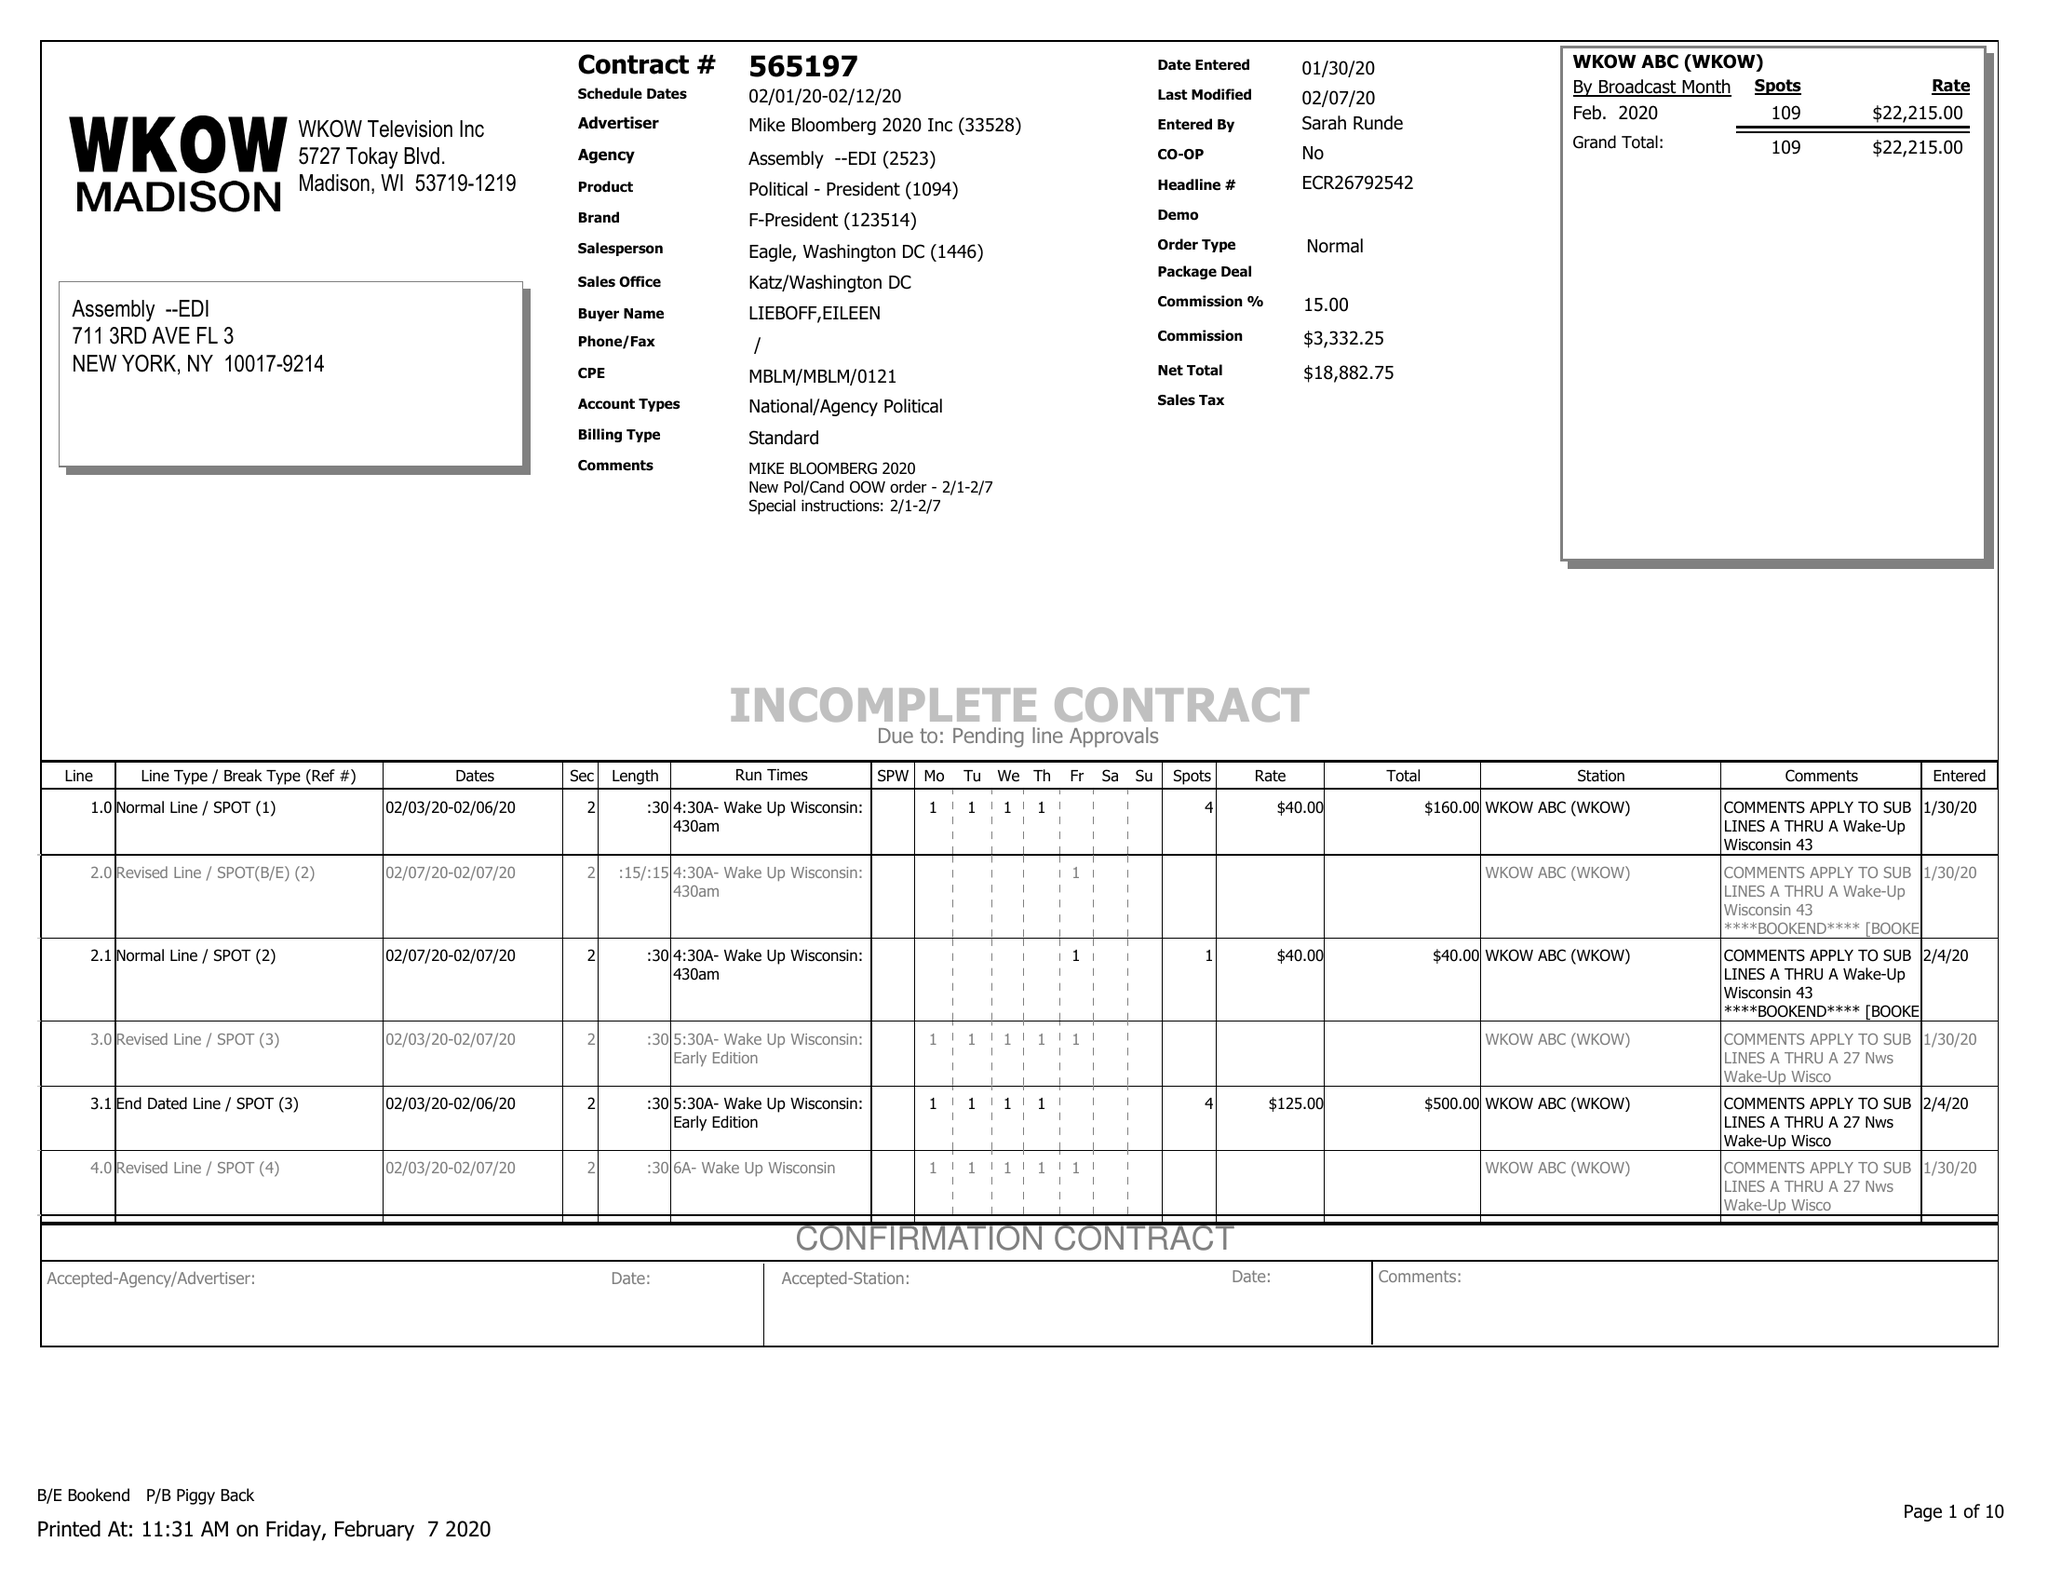What is the value for the flight_to?
Answer the question using a single word or phrase. 02/12/20 